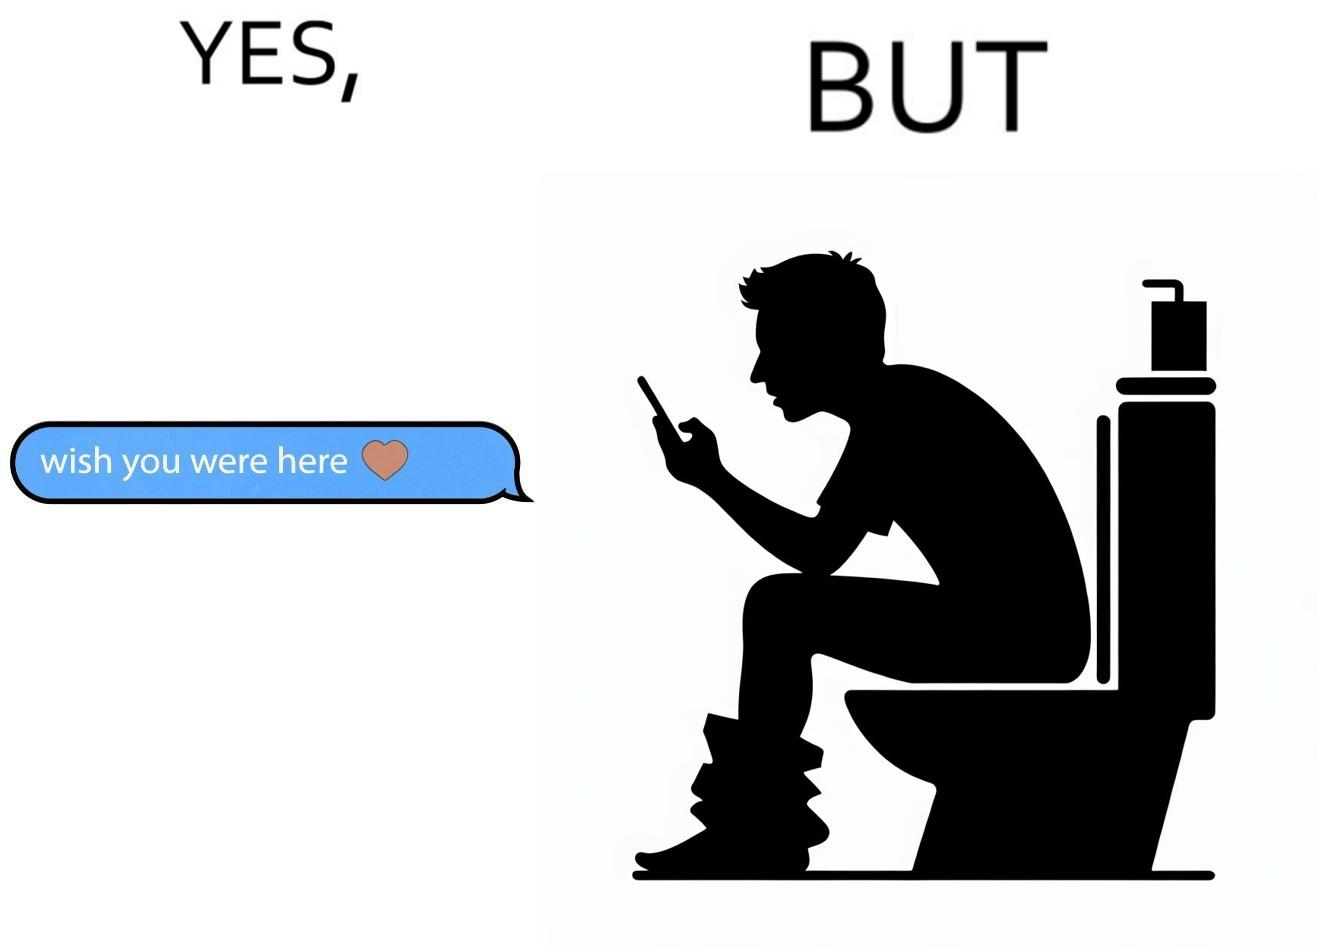What is shown in the left half versus the right half of this image? In the left part of the image: It is a text saying "i wish you were here" indicating that someone is missing their partner In the right part of the image: It is a man using his phone while using a toilet 